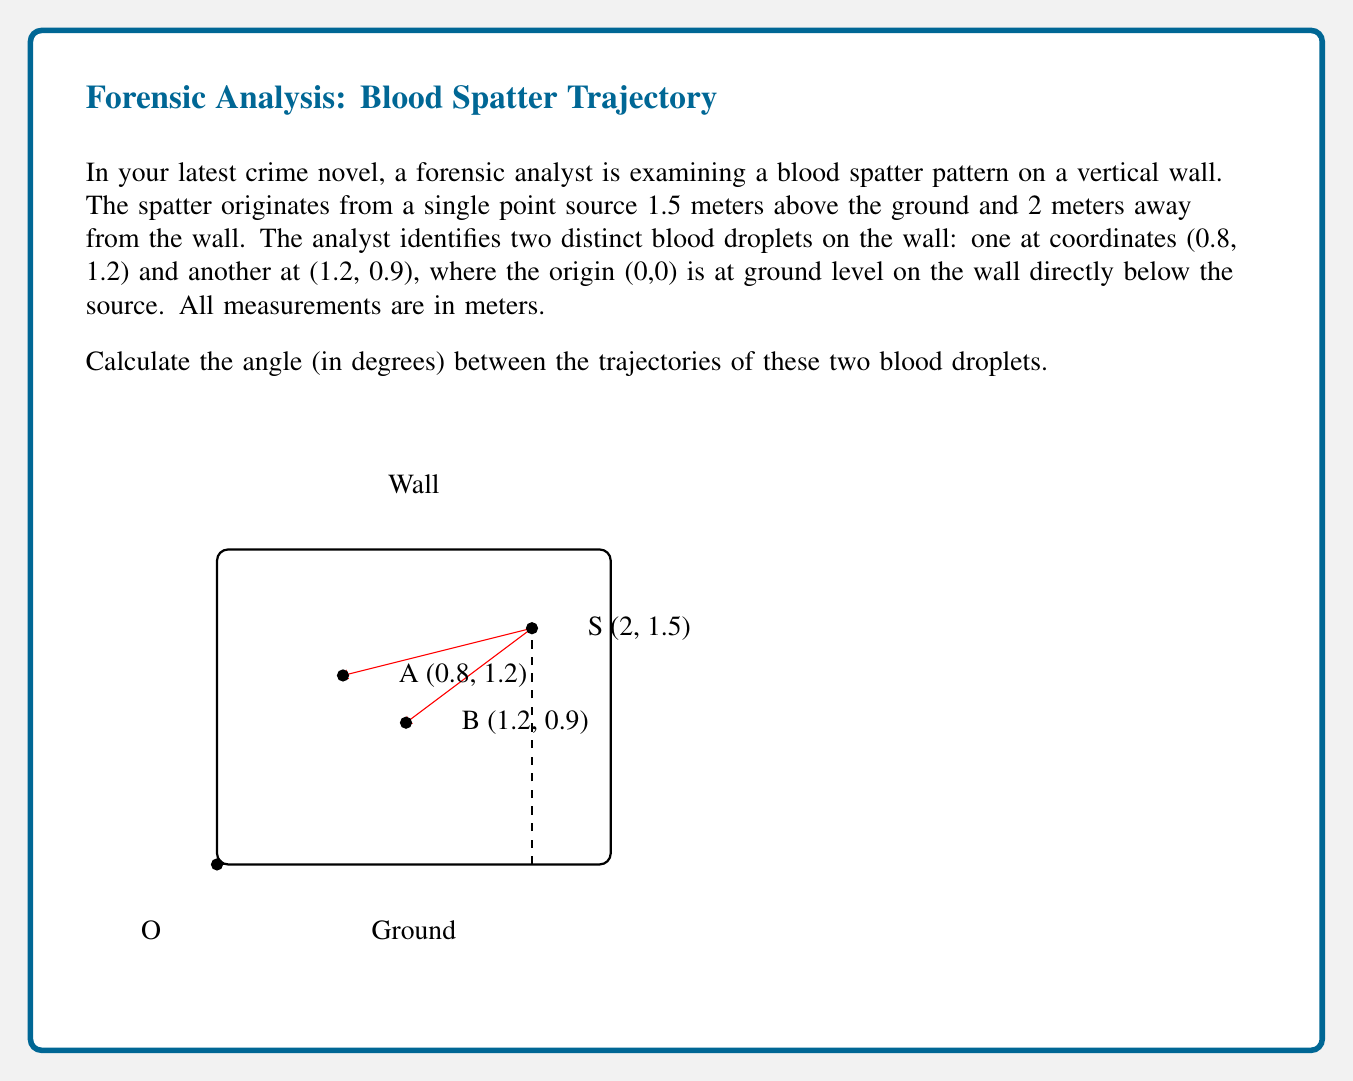Give your solution to this math problem. Let's approach this step-by-step:

1) First, we need to find the vectors from the source point S to each of the droplets A and B.

   $\vec{SA} = (0.8 - 2, 1.2 - 1.5) = (-1.2, -0.3)$
   $\vec{SB} = (1.2 - 2, 0.9 - 1.5) = (-0.8, -0.6)$

2) To find the angle between these vectors, we can use the dot product formula:

   $\cos \theta = \frac{\vec{SA} \cdot \vec{SB}}{|\vec{SA}| |\vec{SB}|}$

3) Let's calculate each part:

   $\vec{SA} \cdot \vec{SB} = (-1.2)(-0.8) + (-0.3)(-0.6) = 0.96 + 0.18 = 1.14$

   $|\vec{SA}| = \sqrt{(-1.2)^2 + (-0.3)^2} = \sqrt{1.44 + 0.09} = \sqrt{1.53} \approx 1.2369$

   $|\vec{SB}| = \sqrt{(-0.8)^2 + (-0.6)^2} = \sqrt{0.64 + 0.36} = \sqrt{1} = 1$

4) Now we can substitute these values into the formula:

   $\cos \theta = \frac{1.14}{1.2369 \cdot 1} \approx 0.9217$

5) To get the angle, we take the inverse cosine (arccos) and convert to degrees:

   $\theta = \arccos(0.9217) \approx 0.3980 \text{ radians}$

   $\theta \approx 0.3980 \cdot \frac{180^{\circ}}{\pi} \approx 22.81^{\circ}$
Answer: $22.81^{\circ}$ 